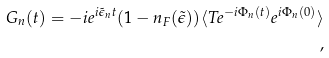<formula> <loc_0><loc_0><loc_500><loc_500>G _ { n } ( t ) = - i e ^ { i \tilde { \epsilon } _ { n } t } ( 1 - n _ { F } ( \tilde { \epsilon } ) ) \langle T e ^ { - i \Phi _ { n } ( t ) } e ^ { i \Phi _ { n } ( 0 ) } \rangle \\ ,</formula> 